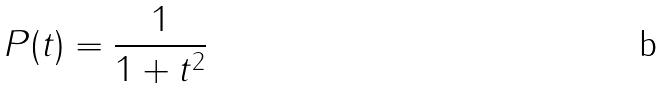<formula> <loc_0><loc_0><loc_500><loc_500>P ( t ) = \frac { 1 } { 1 + t ^ { 2 } }</formula> 